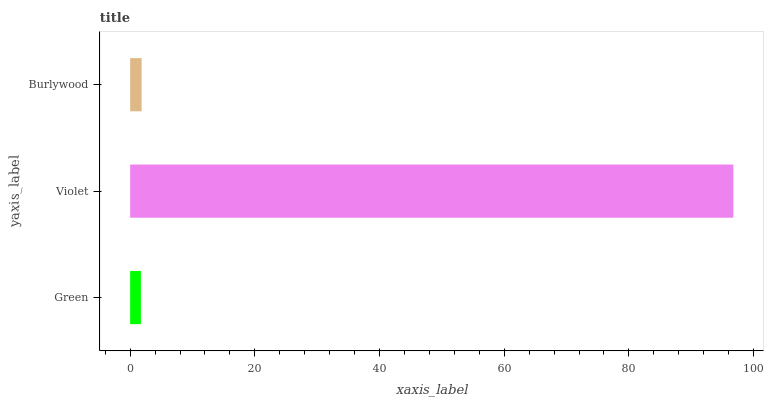Is Green the minimum?
Answer yes or no. Yes. Is Violet the maximum?
Answer yes or no. Yes. Is Burlywood the minimum?
Answer yes or no. No. Is Burlywood the maximum?
Answer yes or no. No. Is Violet greater than Burlywood?
Answer yes or no. Yes. Is Burlywood less than Violet?
Answer yes or no. Yes. Is Burlywood greater than Violet?
Answer yes or no. No. Is Violet less than Burlywood?
Answer yes or no. No. Is Burlywood the high median?
Answer yes or no. Yes. Is Burlywood the low median?
Answer yes or no. Yes. Is Violet the high median?
Answer yes or no. No. Is Violet the low median?
Answer yes or no. No. 